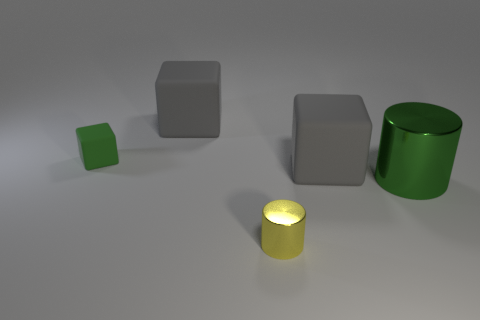There is a metallic object that is to the left of the big green thing; is it the same shape as the green thing on the right side of the yellow shiny cylinder?
Your answer should be compact. Yes. There is a matte object that is on the right side of the green matte object and left of the tiny cylinder; what is its size?
Provide a succinct answer. Large. What color is the other metallic object that is the same shape as the yellow metal thing?
Your answer should be very brief. Green. What is the color of the cylinder on the left side of the big gray thing to the right of the small yellow shiny object?
Offer a terse response. Yellow. The tiny rubber thing has what shape?
Ensure brevity in your answer.  Cube. There is a big thing that is both right of the small yellow metallic object and on the left side of the green metal cylinder; what shape is it?
Keep it short and to the point. Cube. There is a object that is the same material as the large green cylinder; what is its color?
Provide a succinct answer. Yellow. There is a large rubber thing that is on the left side of the object in front of the cylinder on the right side of the tiny yellow object; what shape is it?
Offer a terse response. Cube. What is the size of the green block?
Offer a very short reply. Small. Is the number of large matte things behind the small cube less than the number of yellow metal things?
Give a very brief answer. No. 